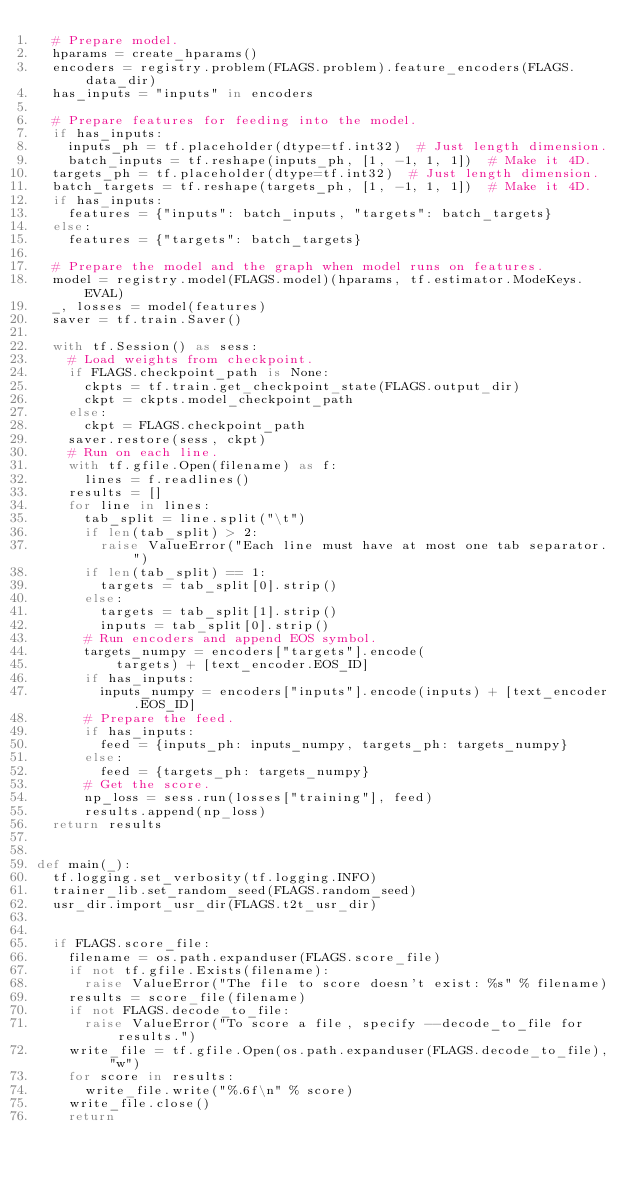Convert code to text. <code><loc_0><loc_0><loc_500><loc_500><_Python_>  # Prepare model.
  hparams = create_hparams()
  encoders = registry.problem(FLAGS.problem).feature_encoders(FLAGS.data_dir)
  has_inputs = "inputs" in encoders

  # Prepare features for feeding into the model.
  if has_inputs:
    inputs_ph = tf.placeholder(dtype=tf.int32)  # Just length dimension.
    batch_inputs = tf.reshape(inputs_ph, [1, -1, 1, 1])  # Make it 4D.
  targets_ph = tf.placeholder(dtype=tf.int32)  # Just length dimension.
  batch_targets = tf.reshape(targets_ph, [1, -1, 1, 1])  # Make it 4D.
  if has_inputs:
    features = {"inputs": batch_inputs, "targets": batch_targets}
  else:
    features = {"targets": batch_targets}

  # Prepare the model and the graph when model runs on features.
  model = registry.model(FLAGS.model)(hparams, tf.estimator.ModeKeys.EVAL)
  _, losses = model(features)
  saver = tf.train.Saver()

  with tf.Session() as sess:
    # Load weights from checkpoint.
    if FLAGS.checkpoint_path is None:
      ckpts = tf.train.get_checkpoint_state(FLAGS.output_dir)
      ckpt = ckpts.model_checkpoint_path
    else:
      ckpt = FLAGS.checkpoint_path
    saver.restore(sess, ckpt)
    # Run on each line.
    with tf.gfile.Open(filename) as f:
      lines = f.readlines()
    results = []
    for line in lines:
      tab_split = line.split("\t")
      if len(tab_split) > 2:
        raise ValueError("Each line must have at most one tab separator.")
      if len(tab_split) == 1:
        targets = tab_split[0].strip()
      else:
        targets = tab_split[1].strip()
        inputs = tab_split[0].strip()
      # Run encoders and append EOS symbol.
      targets_numpy = encoders["targets"].encode(
          targets) + [text_encoder.EOS_ID]
      if has_inputs:
        inputs_numpy = encoders["inputs"].encode(inputs) + [text_encoder.EOS_ID]
      # Prepare the feed.
      if has_inputs:
        feed = {inputs_ph: inputs_numpy, targets_ph: targets_numpy}
      else:
        feed = {targets_ph: targets_numpy}
      # Get the score.
      np_loss = sess.run(losses["training"], feed)
      results.append(np_loss)
  return results


def main(_):
  tf.logging.set_verbosity(tf.logging.INFO)
  trainer_lib.set_random_seed(FLAGS.random_seed)
  usr_dir.import_usr_dir(FLAGS.t2t_usr_dir)


  if FLAGS.score_file:
    filename = os.path.expanduser(FLAGS.score_file)
    if not tf.gfile.Exists(filename):
      raise ValueError("The file to score doesn't exist: %s" % filename)
    results = score_file(filename)
    if not FLAGS.decode_to_file:
      raise ValueError("To score a file, specify --decode_to_file for results.")
    write_file = tf.gfile.Open(os.path.expanduser(FLAGS.decode_to_file), "w")
    for score in results:
      write_file.write("%.6f\n" % score)
    write_file.close()
    return
</code> 